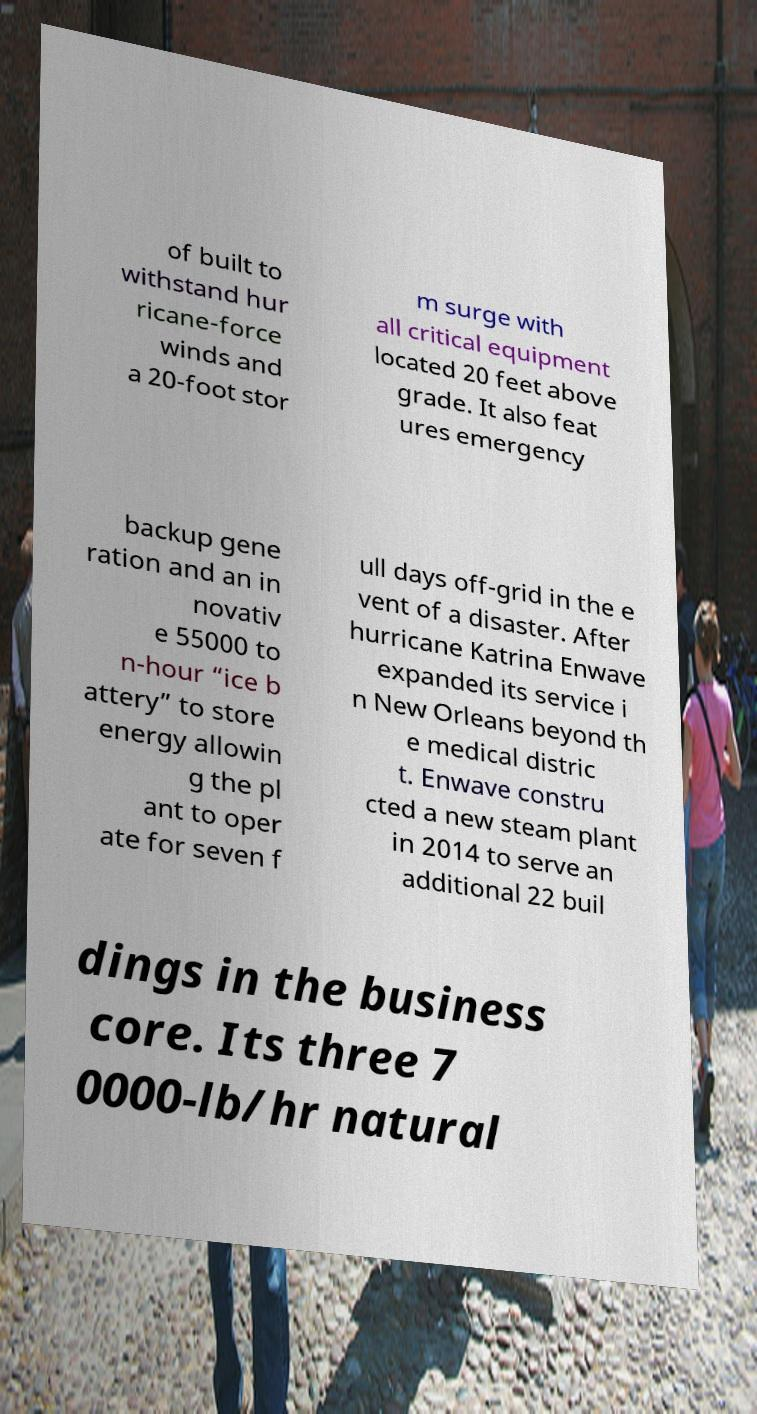Please read and relay the text visible in this image. What does it say? of built to withstand hur ricane-force winds and a 20-foot stor m surge with all critical equipment located 20 feet above grade. It also feat ures emergency backup gene ration and an in novativ e 55000 to n-hour “ice b attery” to store energy allowin g the pl ant to oper ate for seven f ull days off-grid in the e vent of a disaster. After hurricane Katrina Enwave expanded its service i n New Orleans beyond th e medical distric t. Enwave constru cted a new steam plant in 2014 to serve an additional 22 buil dings in the business core. Its three 7 0000-lb/hr natural 